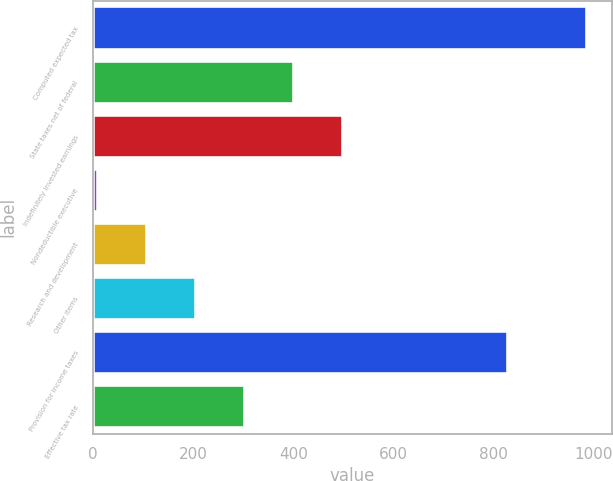Convert chart. <chart><loc_0><loc_0><loc_500><loc_500><bar_chart><fcel>Computed expected tax<fcel>State taxes net of federal<fcel>Indefinitely invested earnings<fcel>Nondeductible executive<fcel>Research and development<fcel>Other items<fcel>Provision for income taxes<fcel>Effective tax rate<nl><fcel>987<fcel>401.4<fcel>499<fcel>11<fcel>108.6<fcel>206.2<fcel>829<fcel>303.8<nl></chart> 